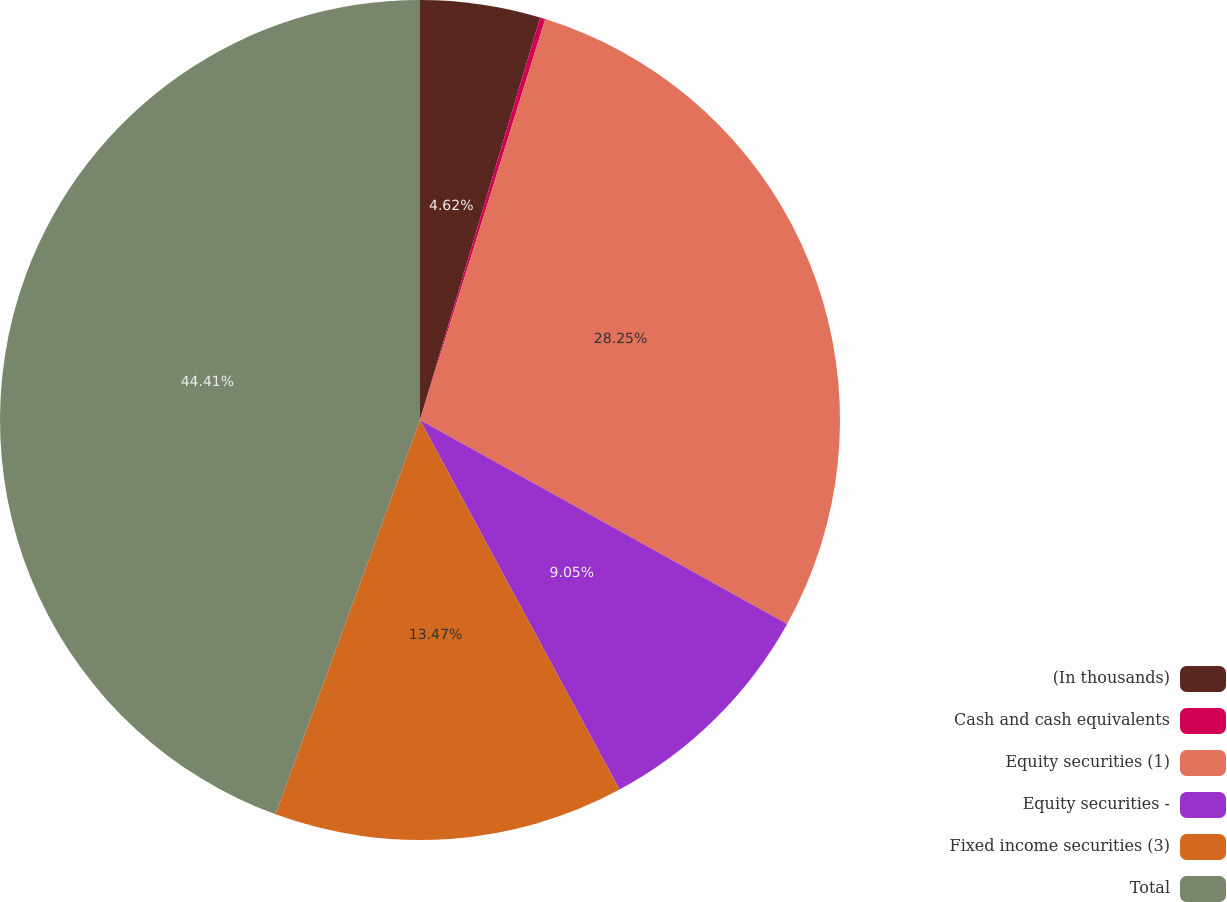Convert chart. <chart><loc_0><loc_0><loc_500><loc_500><pie_chart><fcel>(In thousands)<fcel>Cash and cash equivalents<fcel>Equity securities (1)<fcel>Equity securities -<fcel>Fixed income securities (3)<fcel>Total<nl><fcel>4.62%<fcel>0.2%<fcel>28.25%<fcel>9.05%<fcel>13.47%<fcel>44.41%<nl></chart> 